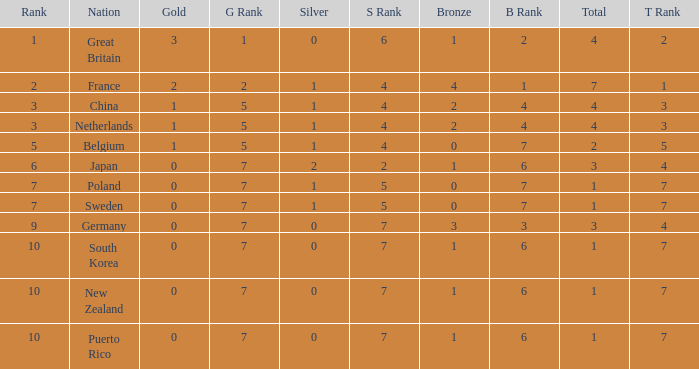What is the total where the gold is larger than 2? 1.0. 